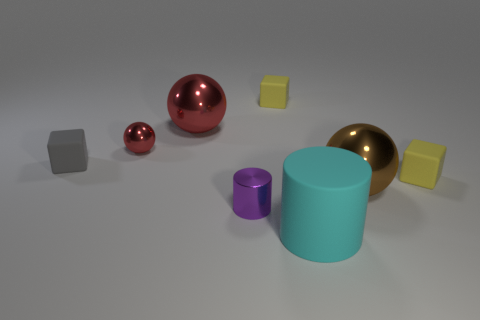Subtract 1 balls. How many balls are left? 2 Add 1 tiny matte cubes. How many objects exist? 9 Subtract all spheres. How many objects are left? 5 Add 6 big red balls. How many big red balls are left? 7 Add 4 big brown shiny spheres. How many big brown shiny spheres exist? 5 Subtract 0 gray balls. How many objects are left? 8 Subtract all red balls. Subtract all gray metallic spheres. How many objects are left? 6 